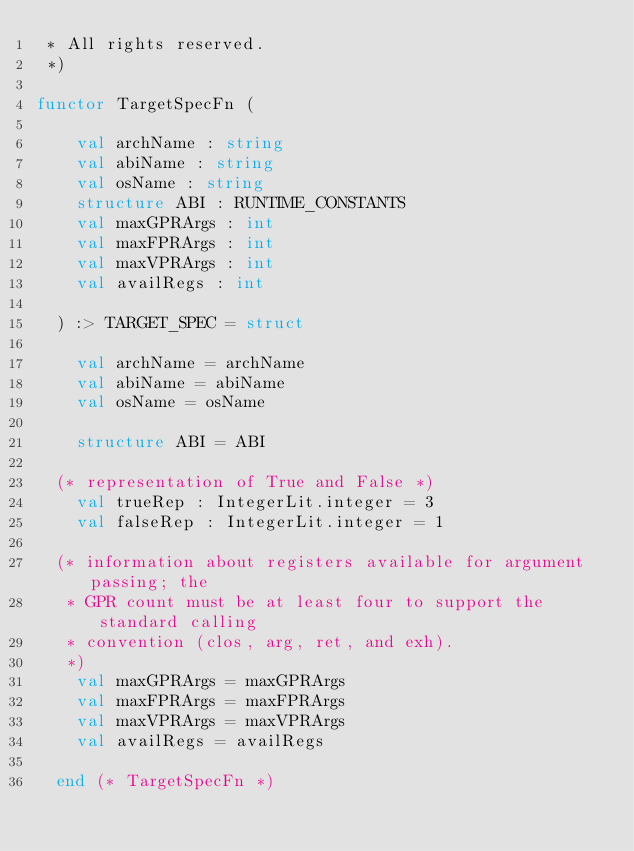Convert code to text. <code><loc_0><loc_0><loc_500><loc_500><_SML_> * All rights reserved.
 *)

functor TargetSpecFn (

    val archName : string
    val abiName : string
    val osName : string
    structure ABI : RUNTIME_CONSTANTS
    val maxGPRArgs : int
    val maxFPRArgs : int
    val maxVPRArgs : int
    val availRegs : int

  ) :> TARGET_SPEC = struct

    val archName = archName
    val abiName = abiName
    val osName = osName

    structure ABI = ABI

  (* representation of True and False *)
    val trueRep : IntegerLit.integer = 3
    val falseRep : IntegerLit.integer = 1

  (* information about registers available for argument passing; the
   * GPR count must be at least four to support the standard calling
   * convention (clos, arg, ret, and exh).
   *)
    val maxGPRArgs = maxGPRArgs
    val maxFPRArgs = maxFPRArgs
    val maxVPRArgs = maxVPRArgs
    val availRegs = availRegs

  end (* TargetSpecFn *)
</code> 